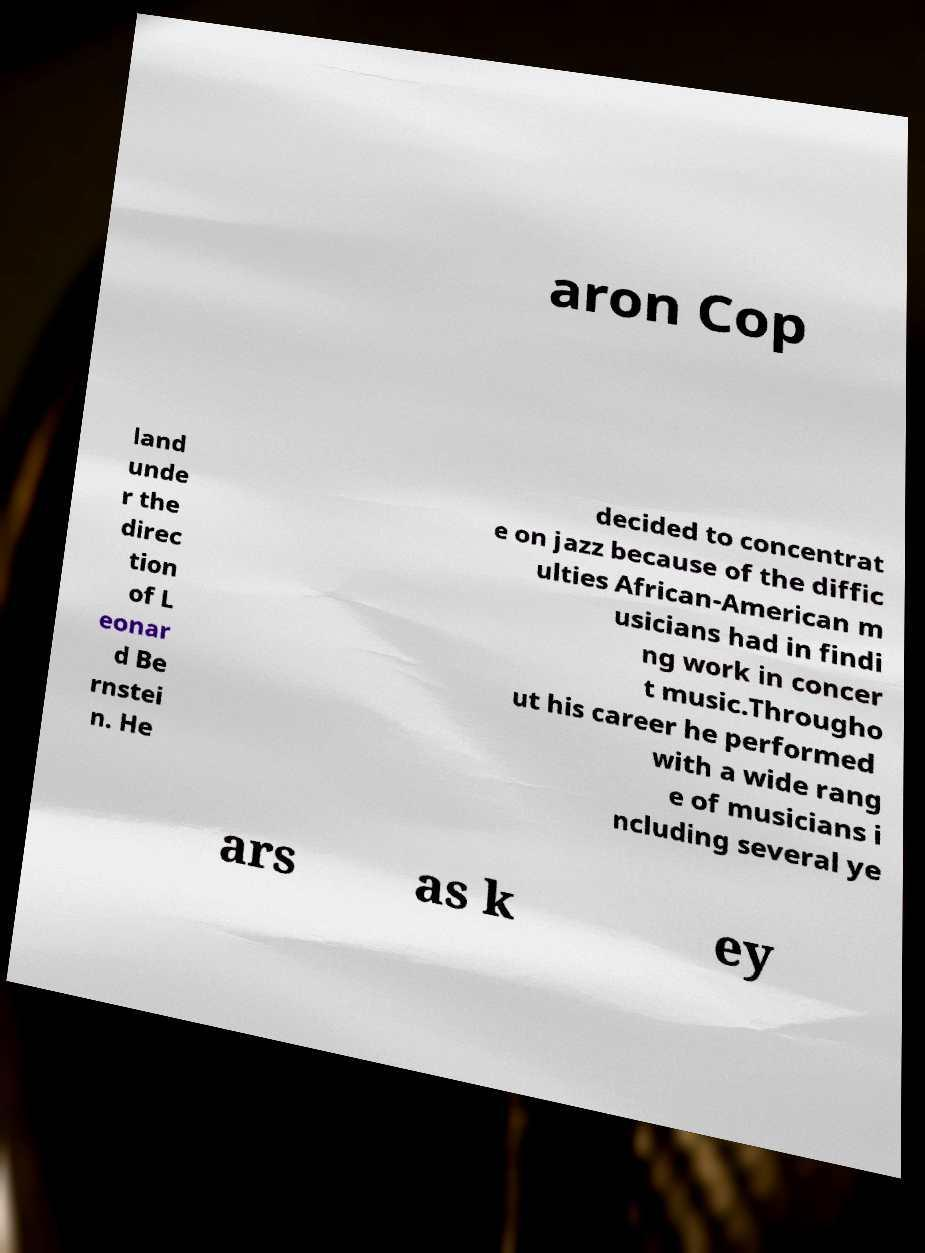What messages or text are displayed in this image? I need them in a readable, typed format. aron Cop land unde r the direc tion of L eonar d Be rnstei n. He decided to concentrat e on jazz because of the diffic ulties African-American m usicians had in findi ng work in concer t music.Througho ut his career he performed with a wide rang e of musicians i ncluding several ye ars as k ey 